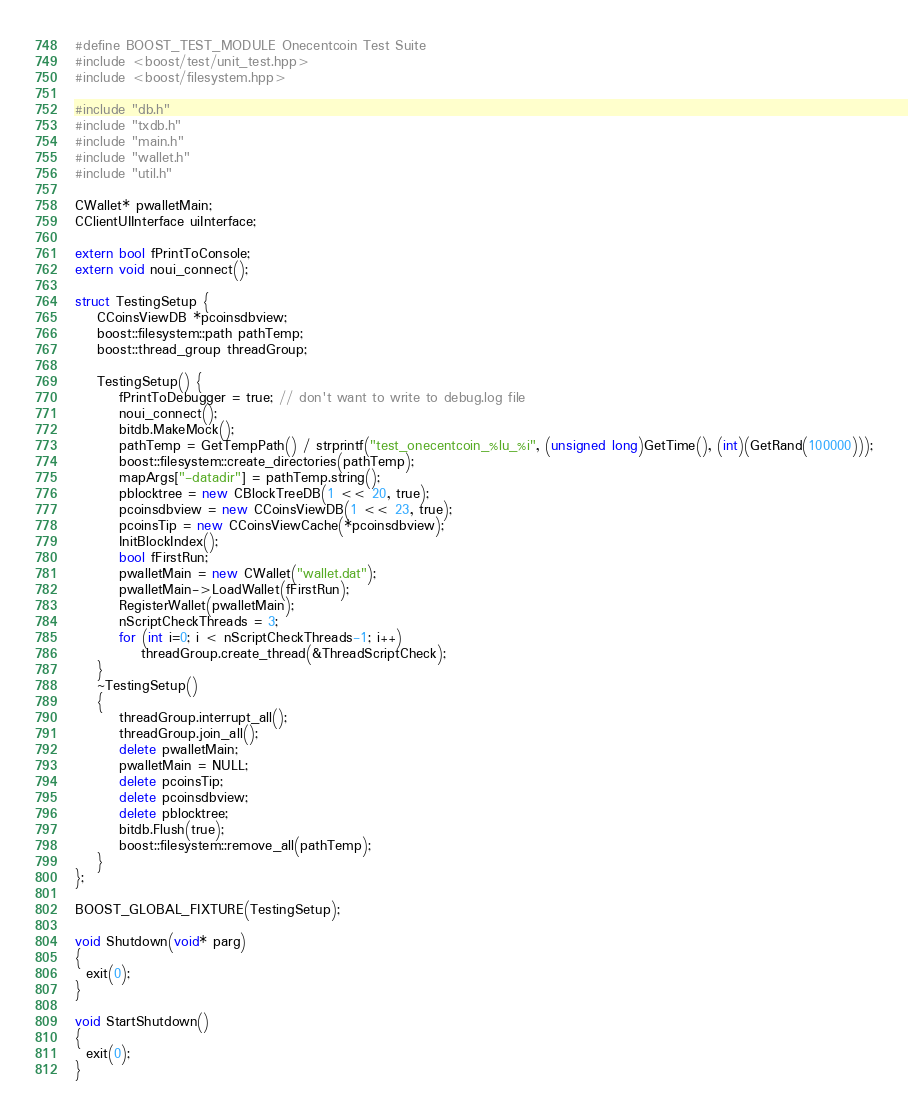<code> <loc_0><loc_0><loc_500><loc_500><_C++_>#define BOOST_TEST_MODULE Onecentcoin Test Suite
#include <boost/test/unit_test.hpp>
#include <boost/filesystem.hpp>

#include "db.h"
#include "txdb.h"
#include "main.h"
#include "wallet.h"
#include "util.h"

CWallet* pwalletMain;
CClientUIInterface uiInterface;

extern bool fPrintToConsole;
extern void noui_connect();

struct TestingSetup {
    CCoinsViewDB *pcoinsdbview;
    boost::filesystem::path pathTemp;
    boost::thread_group threadGroup;

    TestingSetup() {
        fPrintToDebugger = true; // don't want to write to debug.log file
        noui_connect();
        bitdb.MakeMock();
        pathTemp = GetTempPath() / strprintf("test_onecentcoin_%lu_%i", (unsigned long)GetTime(), (int)(GetRand(100000)));
        boost::filesystem::create_directories(pathTemp);
        mapArgs["-datadir"] = pathTemp.string();
        pblocktree = new CBlockTreeDB(1 << 20, true);
        pcoinsdbview = new CCoinsViewDB(1 << 23, true);
        pcoinsTip = new CCoinsViewCache(*pcoinsdbview);
        InitBlockIndex();
        bool fFirstRun;
        pwalletMain = new CWallet("wallet.dat");
        pwalletMain->LoadWallet(fFirstRun);
        RegisterWallet(pwalletMain);
        nScriptCheckThreads = 3;
        for (int i=0; i < nScriptCheckThreads-1; i++)
            threadGroup.create_thread(&ThreadScriptCheck);
    }
    ~TestingSetup()
    {
        threadGroup.interrupt_all();
        threadGroup.join_all();
        delete pwalletMain;
        pwalletMain = NULL;
        delete pcoinsTip;
        delete pcoinsdbview;
        delete pblocktree;
        bitdb.Flush(true);
        boost::filesystem::remove_all(pathTemp);
    }
};

BOOST_GLOBAL_FIXTURE(TestingSetup);

void Shutdown(void* parg)
{
  exit(0);
}

void StartShutdown()
{
  exit(0);
}

</code> 